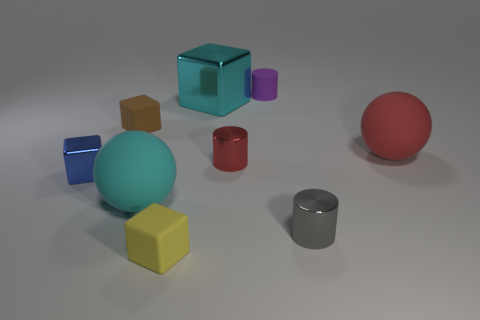Subtract all blocks. How many objects are left? 5 Add 8 yellow matte objects. How many yellow matte objects exist? 9 Subtract 0 yellow cylinders. How many objects are left? 9 Subtract all large matte cylinders. Subtract all cylinders. How many objects are left? 6 Add 4 yellow matte blocks. How many yellow matte blocks are left? 5 